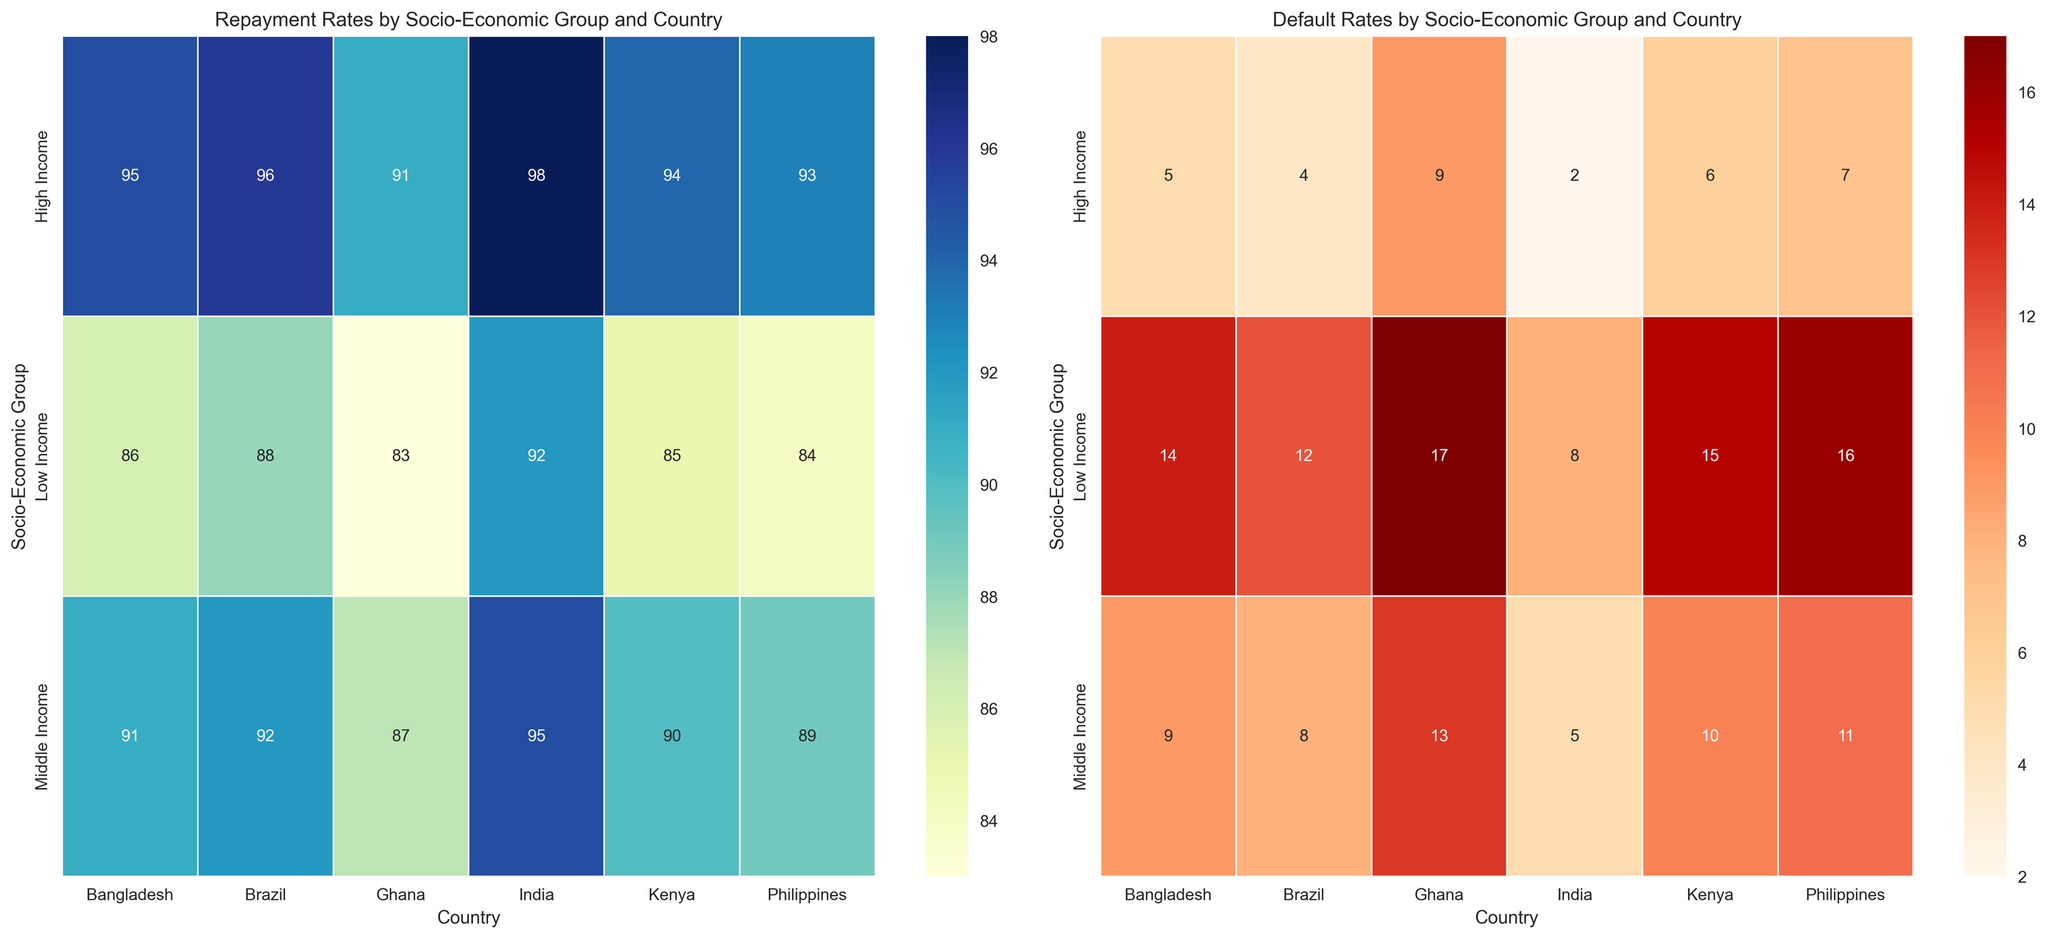What is the repayment rate for low-income groups in Ghana and Bangladesh combined? For Ghana, the repayment rate for the low-income group is 83%, and for Bangladesh, it is 86%. To find the combined repayment rate, we find the average: (83 + 86) / 2 = 169 / 2 = 84.5.
Answer: 84.5% Which country has the lowest default rate for high-income groups? To determine the country with the lowest default rate for high-income groups, we examine the default rates for high-income groups: India (2%), Kenya (6%), Brazil (4%), Philippines (7%), Ghana (9%), and Bangladesh (5%). The lowest of these is India's 2%.
Answer: India Between Brazil and Kenya, which middle-income group has a higher repayment rate, and by how much? For Brazil, the middle-income group's repayment rate is 92%. For Kenya, it is 90%. The difference is 92 - 90 = 2%. Brazil has a higher repayment rate by 2%.
Answer: Brazil, by 2% What is the average default rate across all socio-economic groups in the Philippines? The default rates for the Philippines are: Low Income (16%), Middle Income (11%), and High Income (7%). The average is calculated as follows: (16 + 11 + 7) / 3 = 34 / 3 ≈ 11.33.
Answer: 11.33% Which country has the highest variation in repayment rates among different socio-economic groups? The variation can be assessed by taking the difference between the highest and lowest repayment rates for each country. India: 98 - 92 = 6. Kenya: 94 - 85 = 9. Brazil: 96 - 88 = 8. Philippines: 93 - 84 = 9. Ghana: 91 - 83 = 8. Bangladesh: 95 - 86 = 9. Both Kenya, Philippines, and Bangladesh show the highest variation of 9%.
Answer: Kenya, Philippines, and Bangladesh Which socio-economic group in Ghana has the highest repayment rate? Looking at the Ghana repayment rates, we have Low Income (83%), Middle Income (87%), and High Income (91%). The highest repayment rate is for the High Income group at 91%.
Answer: High Income How many countries have a middle-income repayment rate above 90%? Checking the countries with middle-income repayment rates above 90%, we have: India (95%), Brazil (92%), and Bangladesh (91%). Therefore, three countries meet this criterion.
Answer: 3 Is there a group in the dataset with a default rate higher than 15%? If so, which ones? Examining the default rates, the low-income groups in Kenya (15%), Philippines (16%), and Ghana (17%) have default rates higher than 15%.
Answer: Kenya (Low Income), Philippines (Low Income), Ghana (Low Income) What's the color gradient used to represent high repayment rates in the corresponding heatmap, and how can it help interpret the data visually? The heatmap for repayment rates uses a color gradient from lighter to darker blue, with higher repayment rates represented by darker shades of blue. This makes it easy to visually distinguish areas with higher repayment rates quickly.
Answer: Dark blue indicates high repayment rates 